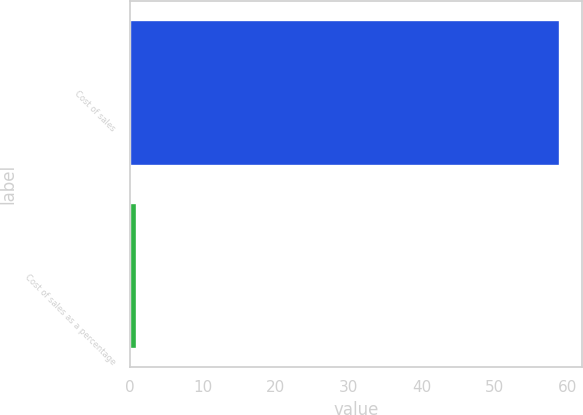Convert chart to OTSL. <chart><loc_0><loc_0><loc_500><loc_500><bar_chart><fcel>Cost of sales<fcel>Cost of sales as a percentage<nl><fcel>59<fcel>1<nl></chart> 